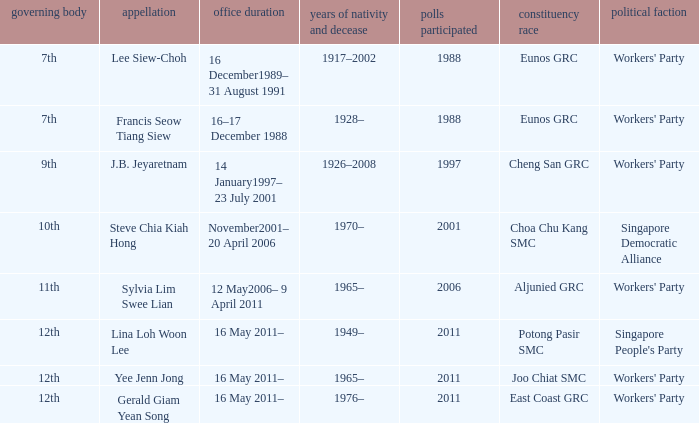What period were conscituency contested is aljunied grc? 12 May2006– 9 April 2011. 